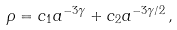Convert formula to latex. <formula><loc_0><loc_0><loc_500><loc_500>\rho = c _ { 1 } a ^ { - 3 \gamma } + c _ { 2 } a ^ { - 3 \gamma / 2 } \, ,</formula> 